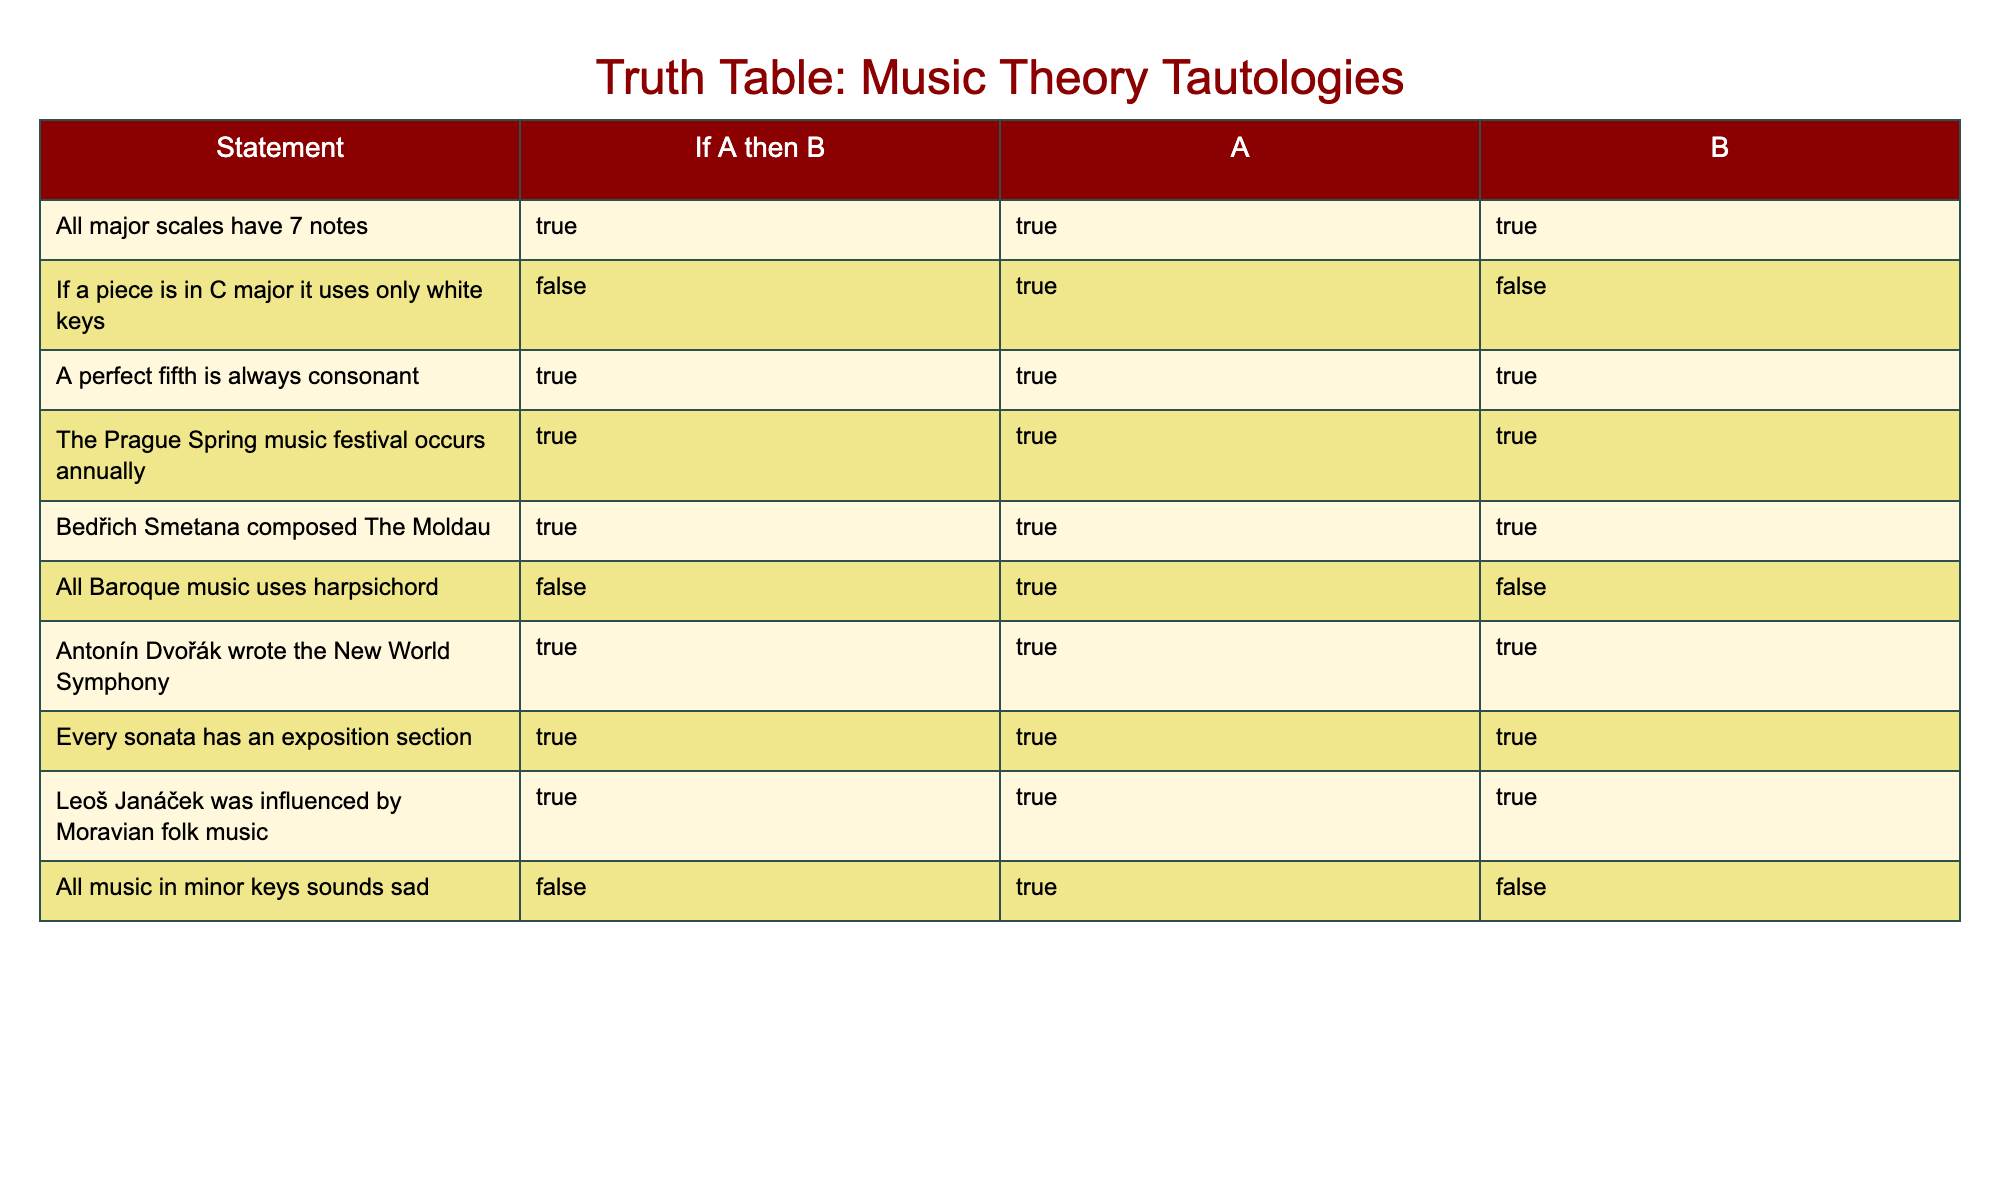What is the statement regarding major scales? The table indicates that "All major scales have 7 notes" and marks it as true. This is straightforward as it's a direct retrieval from the table.
Answer: True What is the truth value for the statement "If a piece is in C major it uses only white keys"? By examining the table, we see this statement is marked as false. It's a direct retrieval of factual information from the relevant row of the table.
Answer: False How many true statements are there in total? We count each row in the table where the statement is labeled as true. There are 7 statements labeled as true out of 10 total statements in the table. Thus, there are 7 true statements.
Answer: 7 Is "All Baroque music uses harpsichord" a true statement? By checking the row for the statement, we find it is marked as false in the table. This is a simple fact-based question.
Answer: False What can be inferred about Antonín Dvořák's works from the table? The table indicates that "Antonín Dvořák wrote the New World Symphony," which is marked as true. This means it’s a confirmed fact that can be retrieved directly from the table.
Answer: True Which statement mentions a connection to folk music? The table states "Leoš Janáček was influenced by Moravian folk music," which is marked as true. This is a direct retrieval from the table.
Answer: True What is the relationship between major and minor scales according to the statements in the table? The statements collectively indicate that "All major scales have 7 notes" and "All music in minor keys sounds sad," but the latter is marked as false. This means the assertion about all minor music may not be valid. Hence, there is no established direct relationship from these statements, highlighting a complexity in musical theory.
Answer: No direct relationship established How many statements are about specific composers and their compositions? The table lists three composer-specific statements: about Bedřich Smetana, Antonín Dvořák, and their respective works, giving a count of 3 such statements in the table.
Answer: 3 What is the conclusion regarding the Prague Spring music festival from the table? The statement indicates "The Prague Spring music festival occurs annually" and is marked true. This tells us that the festival is indeed recognized as an annual event.
Answer: True 